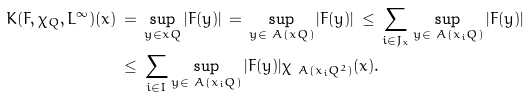<formula> <loc_0><loc_0><loc_500><loc_500>K ( F , \chi _ { Q } , L ^ { \infty } ) ( x ) \, & = \, \sup _ { y \in x Q } | F ( y ) | \, = \, \sup _ { y \in \ A ( x Q ) } | F ( y ) | \, \leq \, \sum _ { i \in J _ { x } } \sup _ { y \in \ A ( x _ { i } Q ) } | F ( y ) | \\ & \leq \, \sum _ { i \in I } \sup _ { y \in \ A ( x _ { i } Q ) } | F ( y ) | \chi _ { \ A ( x _ { i } Q ^ { 2 } ) } ( x ) .</formula> 